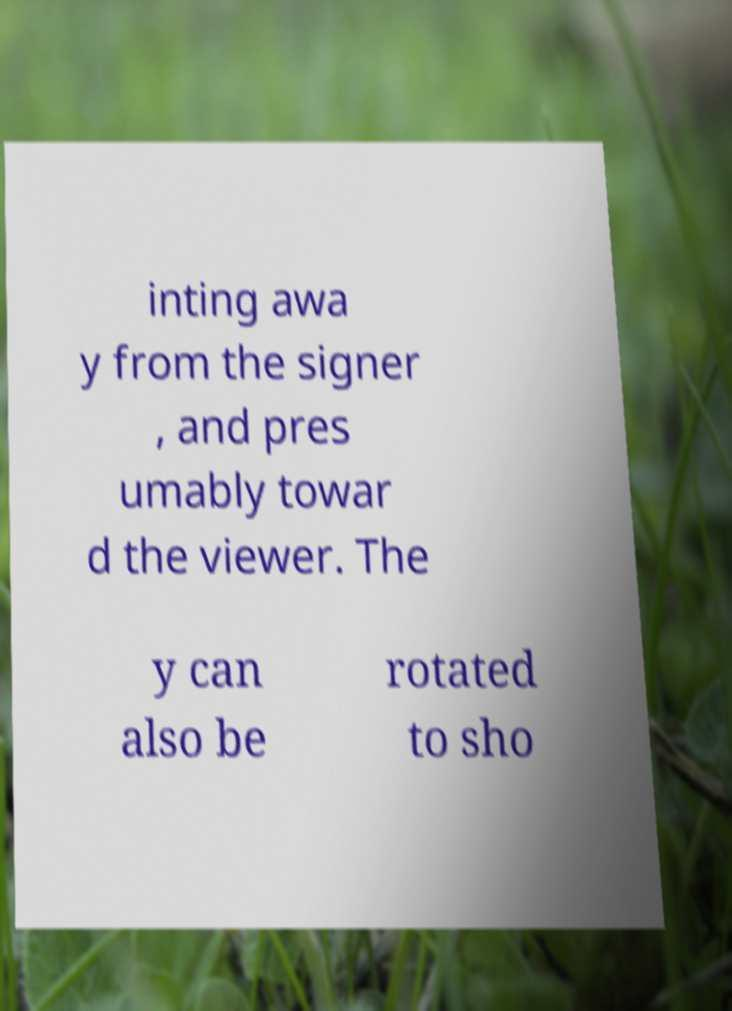Could you extract and type out the text from this image? inting awa y from the signer , and pres umably towar d the viewer. The y can also be rotated to sho 